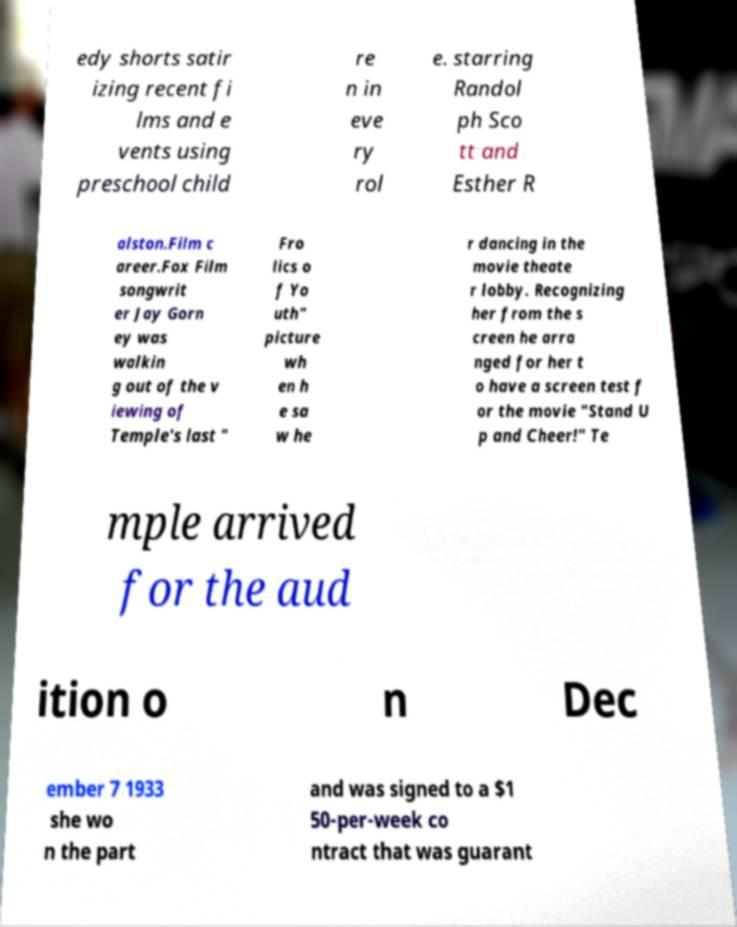I need the written content from this picture converted into text. Can you do that? edy shorts satir izing recent fi lms and e vents using preschool child re n in eve ry rol e. starring Randol ph Sco tt and Esther R alston.Film c areer.Fox Film songwrit er Jay Gorn ey was walkin g out of the v iewing of Temple's last " Fro lics o f Yo uth" picture wh en h e sa w he r dancing in the movie theate r lobby. Recognizing her from the s creen he arra nged for her t o have a screen test f or the movie "Stand U p and Cheer!" Te mple arrived for the aud ition o n Dec ember 7 1933 she wo n the part and was signed to a $1 50-per-week co ntract that was guarant 